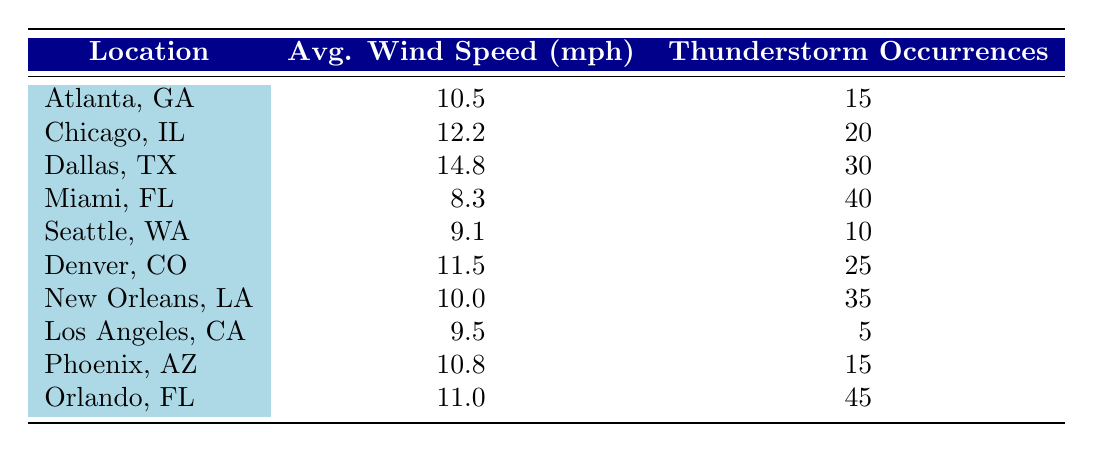What is the average wind speed for Miami, FL? The table shows the average wind speed for Miami, FL as 8.3 mph, which can be found directly in the row corresponding to that location.
Answer: 8.3 mph Which location has the highest number of thunderstorm occurrences? By examining the "Thunderstorm Occurrences" column, Orlando, FL has the highest number at 45 occurrences, as it is greater than the other entries.
Answer: Orlando, FL What is the average wind speed of all locations combined? The total wind speed is the sum of each location's average wind speed: 10.5 + 12.2 + 14.8 + 8.3 + 9.1 + 11.5 + 10.0 + 9.5 + 10.8 + 11.0 =  88.2. There are 10 locations, so the average is 88.2 / 10 = 8.82 mph.
Answer: 8.82 mph Is the average wind speed in Chicago, IL higher than that in Seattle, WA? The average wind speed in Chicago is 12.2 mph while in Seattle it's 9.1 mph. Since 12.2 is greater than 9.1, the answer is yes.
Answer: Yes If we consider only Atlanta, GA, Dallas, TX, and New Orleans, LA, what is the total number of thunderstorm occurrences among these locations? The occurrences are: Atlanta 15, Dallas 30, and New Orleans 35. Adding these gives 15 + 30 + 35 = 80 occurrences total from these locations.
Answer: 80 